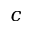Convert formula to latex. <formula><loc_0><loc_0><loc_500><loc_500>c</formula> 